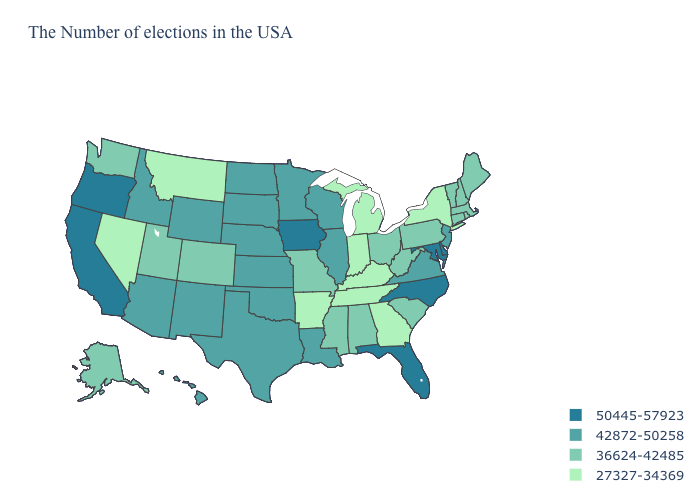Does the map have missing data?
Concise answer only. No. Does Michigan have the lowest value in the MidWest?
Short answer required. Yes. Name the states that have a value in the range 42872-50258?
Short answer required. New Jersey, Virginia, Wisconsin, Illinois, Louisiana, Minnesota, Kansas, Nebraska, Oklahoma, Texas, South Dakota, North Dakota, Wyoming, New Mexico, Arizona, Idaho, Hawaii. What is the value of Washington?
Short answer required. 36624-42485. Does Alaska have the highest value in the West?
Short answer required. No. What is the highest value in states that border Oregon?
Concise answer only. 50445-57923. Does South Dakota have a lower value than Michigan?
Concise answer only. No. Which states have the highest value in the USA?
Be succinct. Delaware, Maryland, North Carolina, Florida, Iowa, California, Oregon. Which states have the highest value in the USA?
Answer briefly. Delaware, Maryland, North Carolina, Florida, Iowa, California, Oregon. Which states hav the highest value in the Northeast?
Short answer required. New Jersey. Does Tennessee have a higher value than Maine?
Short answer required. No. What is the highest value in the Northeast ?
Keep it brief. 42872-50258. Does Vermont have the highest value in the Northeast?
Give a very brief answer. No. What is the value of Georgia?
Answer briefly. 27327-34369. Which states hav the highest value in the MidWest?
Give a very brief answer. Iowa. 